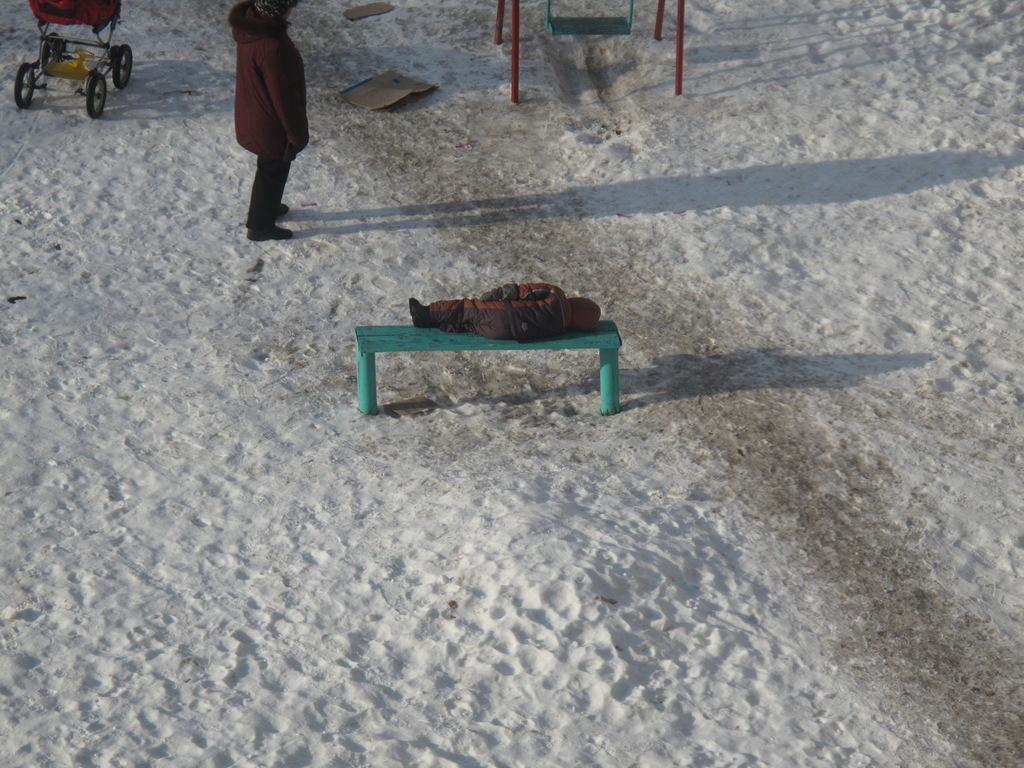Describe this image in one or two sentences. In this image, there are a few people. Among them, we can see a person lying on the bench. We can see the ground covered with snow and some objects. We can also see a baby trolley. We can see some poles and a swing set. 